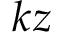<formula> <loc_0><loc_0><loc_500><loc_500>k z</formula> 